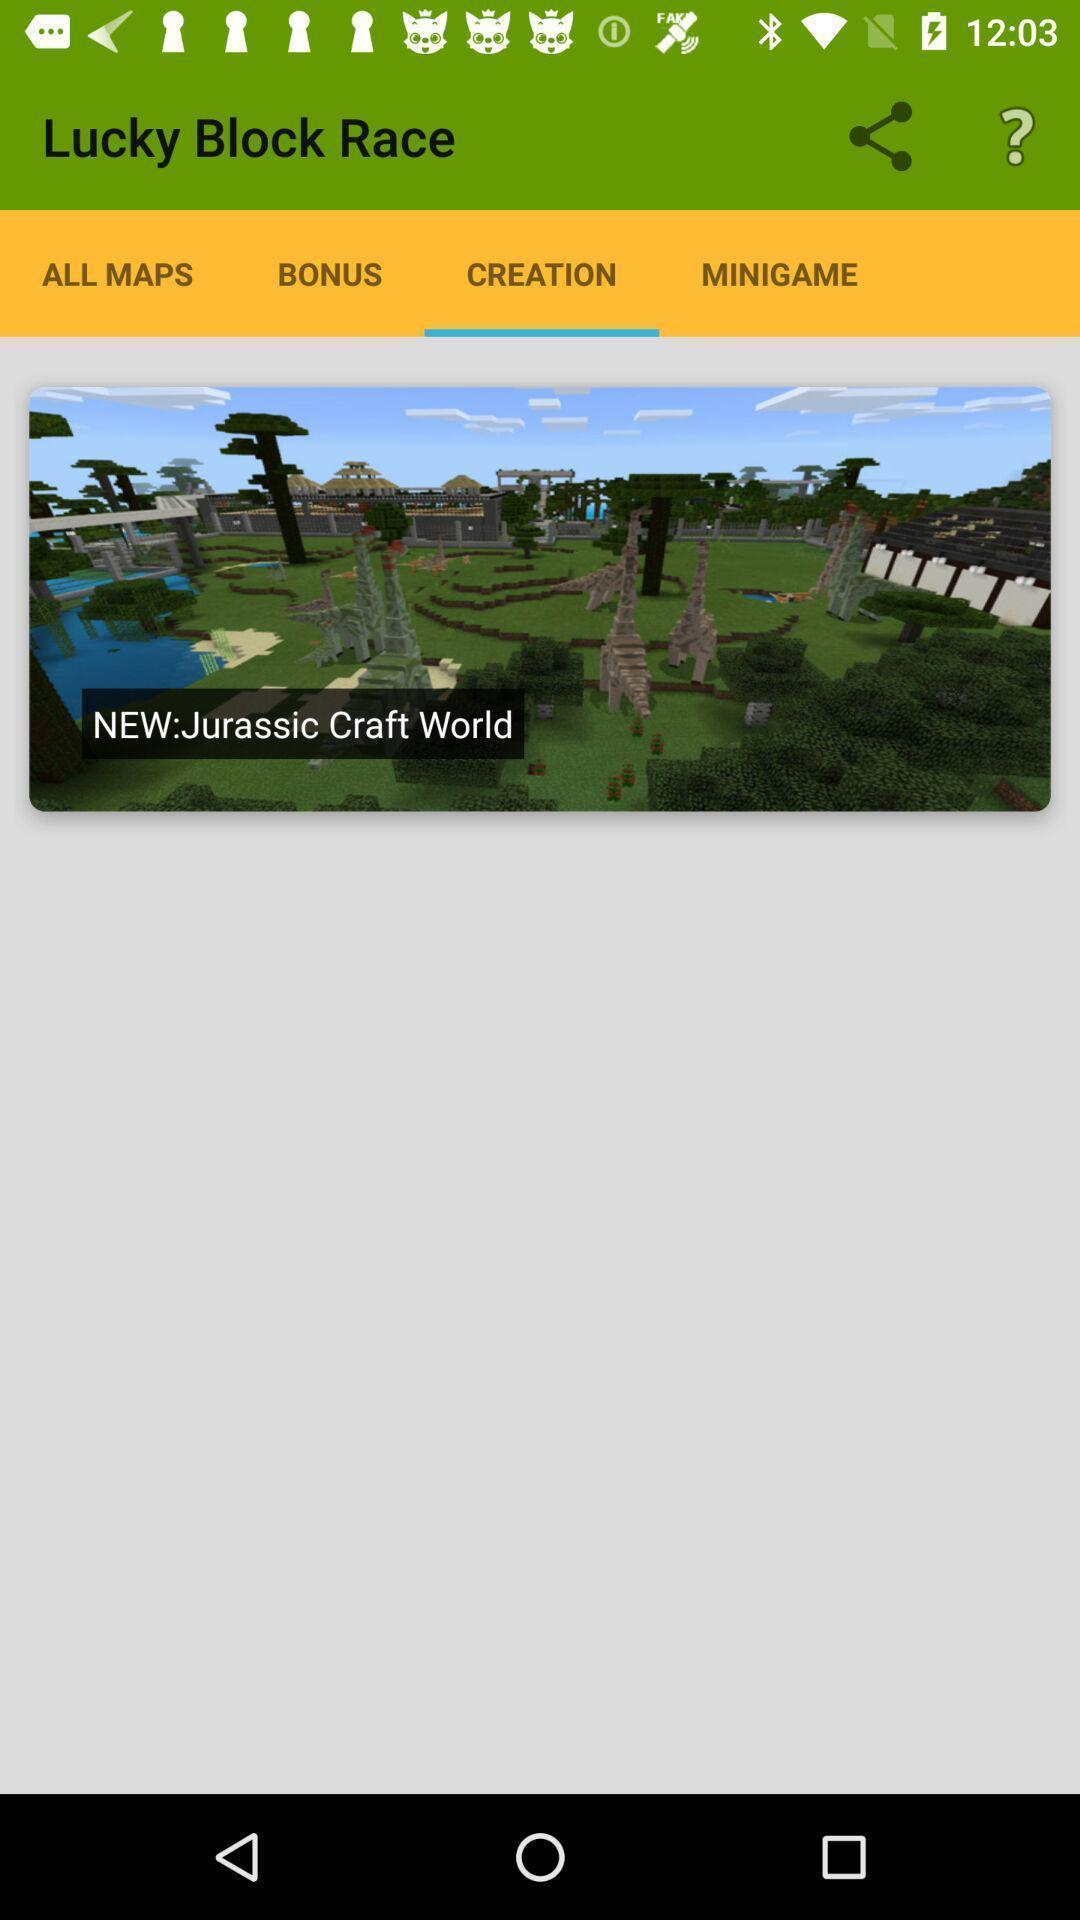Give me a narrative description of this picture. Screen shows multiple options in a gaming app. 